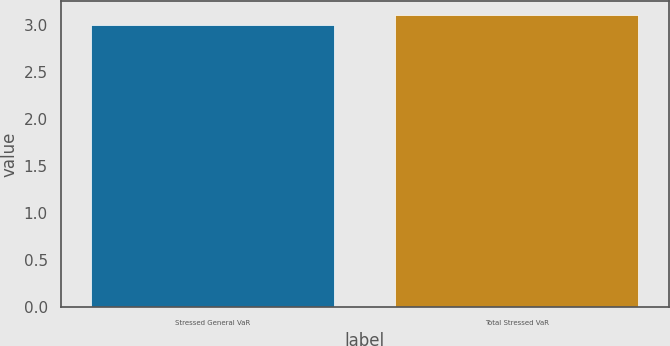Convert chart. <chart><loc_0><loc_0><loc_500><loc_500><bar_chart><fcel>Stressed General VaR<fcel>Total Stressed VaR<nl><fcel>3<fcel>3.1<nl></chart> 